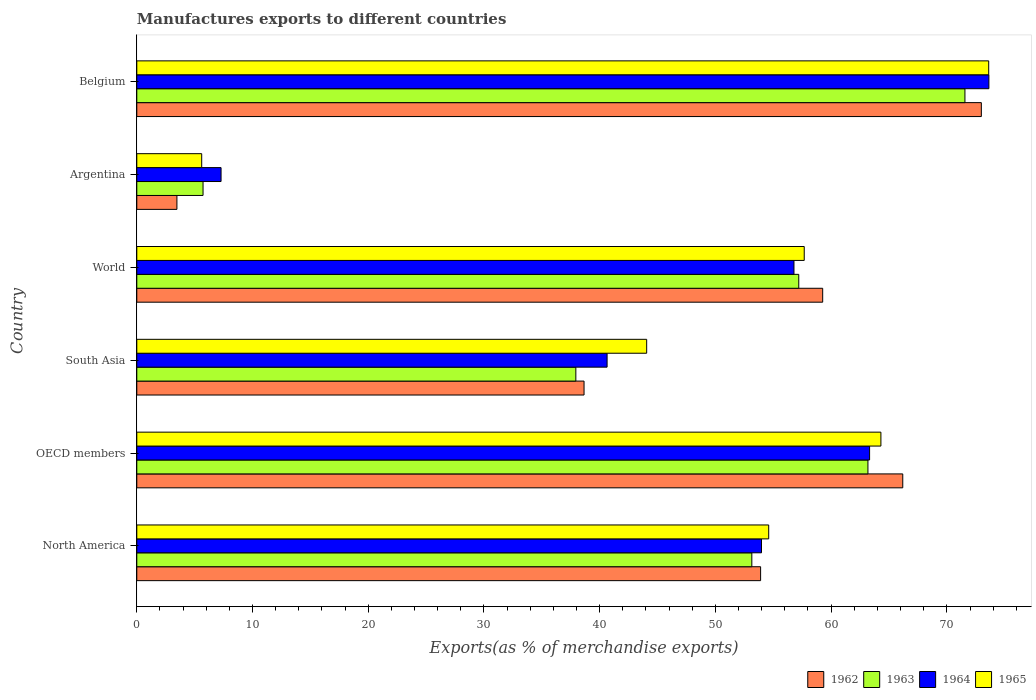How many different coloured bars are there?
Your response must be concise. 4. How many groups of bars are there?
Your answer should be very brief. 6. How many bars are there on the 1st tick from the top?
Give a very brief answer. 4. In how many cases, is the number of bars for a given country not equal to the number of legend labels?
Offer a very short reply. 0. What is the percentage of exports to different countries in 1962 in OECD members?
Keep it short and to the point. 66.19. Across all countries, what is the maximum percentage of exports to different countries in 1964?
Give a very brief answer. 73.63. Across all countries, what is the minimum percentage of exports to different countries in 1964?
Provide a succinct answer. 7.28. In which country was the percentage of exports to different countries in 1962 maximum?
Provide a succinct answer. Belgium. What is the total percentage of exports to different countries in 1963 in the graph?
Keep it short and to the point. 288.76. What is the difference between the percentage of exports to different countries in 1962 in Argentina and that in OECD members?
Keep it short and to the point. -62.72. What is the difference between the percentage of exports to different countries in 1963 in Argentina and the percentage of exports to different countries in 1962 in World?
Keep it short and to the point. -53.54. What is the average percentage of exports to different countries in 1962 per country?
Offer a very short reply. 49.08. What is the difference between the percentage of exports to different countries in 1962 and percentage of exports to different countries in 1965 in North America?
Offer a very short reply. -0.7. What is the ratio of the percentage of exports to different countries in 1963 in Belgium to that in North America?
Your answer should be very brief. 1.35. Is the percentage of exports to different countries in 1962 in OECD members less than that in South Asia?
Give a very brief answer. No. What is the difference between the highest and the second highest percentage of exports to different countries in 1963?
Ensure brevity in your answer.  8.38. What is the difference between the highest and the lowest percentage of exports to different countries in 1962?
Ensure brevity in your answer.  69.51. Is the sum of the percentage of exports to different countries in 1963 in Argentina and OECD members greater than the maximum percentage of exports to different countries in 1965 across all countries?
Make the answer very short. No. What does the 4th bar from the top in Argentina represents?
Offer a very short reply. 1962. What does the 1st bar from the bottom in Argentina represents?
Give a very brief answer. 1962. Are all the bars in the graph horizontal?
Your answer should be compact. Yes. How many countries are there in the graph?
Your response must be concise. 6. What is the difference between two consecutive major ticks on the X-axis?
Your response must be concise. 10. Are the values on the major ticks of X-axis written in scientific E-notation?
Offer a terse response. No. Does the graph contain any zero values?
Provide a succinct answer. No. Does the graph contain grids?
Provide a short and direct response. No. How many legend labels are there?
Give a very brief answer. 4. What is the title of the graph?
Ensure brevity in your answer.  Manufactures exports to different countries. Does "2000" appear as one of the legend labels in the graph?
Offer a very short reply. No. What is the label or title of the X-axis?
Provide a succinct answer. Exports(as % of merchandise exports). What is the label or title of the Y-axis?
Offer a terse response. Country. What is the Exports(as % of merchandise exports) of 1962 in North America?
Make the answer very short. 53.91. What is the Exports(as % of merchandise exports) of 1963 in North America?
Offer a terse response. 53.15. What is the Exports(as % of merchandise exports) in 1964 in North America?
Ensure brevity in your answer.  53.98. What is the Exports(as % of merchandise exports) in 1965 in North America?
Offer a very short reply. 54.61. What is the Exports(as % of merchandise exports) of 1962 in OECD members?
Your answer should be very brief. 66.19. What is the Exports(as % of merchandise exports) in 1963 in OECD members?
Provide a short and direct response. 63.18. What is the Exports(as % of merchandise exports) in 1964 in OECD members?
Keep it short and to the point. 63.32. What is the Exports(as % of merchandise exports) in 1965 in OECD members?
Provide a short and direct response. 64.3. What is the Exports(as % of merchandise exports) of 1962 in South Asia?
Your answer should be very brief. 38.65. What is the Exports(as % of merchandise exports) of 1963 in South Asia?
Make the answer very short. 37.94. What is the Exports(as % of merchandise exports) in 1964 in South Asia?
Your response must be concise. 40.64. What is the Exports(as % of merchandise exports) in 1965 in South Asia?
Offer a very short reply. 44.06. What is the Exports(as % of merchandise exports) in 1962 in World?
Keep it short and to the point. 59.27. What is the Exports(as % of merchandise exports) of 1963 in World?
Provide a succinct answer. 57.2. What is the Exports(as % of merchandise exports) of 1964 in World?
Give a very brief answer. 56.79. What is the Exports(as % of merchandise exports) of 1965 in World?
Your answer should be very brief. 57.68. What is the Exports(as % of merchandise exports) of 1962 in Argentina?
Provide a short and direct response. 3.47. What is the Exports(as % of merchandise exports) in 1963 in Argentina?
Keep it short and to the point. 5.73. What is the Exports(as % of merchandise exports) of 1964 in Argentina?
Give a very brief answer. 7.28. What is the Exports(as % of merchandise exports) of 1965 in Argentina?
Provide a succinct answer. 5.61. What is the Exports(as % of merchandise exports) of 1962 in Belgium?
Your answer should be very brief. 72.98. What is the Exports(as % of merchandise exports) of 1963 in Belgium?
Ensure brevity in your answer.  71.56. What is the Exports(as % of merchandise exports) in 1964 in Belgium?
Provide a succinct answer. 73.63. What is the Exports(as % of merchandise exports) in 1965 in Belgium?
Make the answer very short. 73.62. Across all countries, what is the maximum Exports(as % of merchandise exports) in 1962?
Your response must be concise. 72.98. Across all countries, what is the maximum Exports(as % of merchandise exports) in 1963?
Ensure brevity in your answer.  71.56. Across all countries, what is the maximum Exports(as % of merchandise exports) in 1964?
Your answer should be compact. 73.63. Across all countries, what is the maximum Exports(as % of merchandise exports) of 1965?
Keep it short and to the point. 73.62. Across all countries, what is the minimum Exports(as % of merchandise exports) of 1962?
Your answer should be very brief. 3.47. Across all countries, what is the minimum Exports(as % of merchandise exports) of 1963?
Give a very brief answer. 5.73. Across all countries, what is the minimum Exports(as % of merchandise exports) in 1964?
Ensure brevity in your answer.  7.28. Across all countries, what is the minimum Exports(as % of merchandise exports) in 1965?
Provide a succinct answer. 5.61. What is the total Exports(as % of merchandise exports) in 1962 in the graph?
Your answer should be very brief. 294.46. What is the total Exports(as % of merchandise exports) of 1963 in the graph?
Your answer should be very brief. 288.76. What is the total Exports(as % of merchandise exports) in 1964 in the graph?
Offer a terse response. 295.65. What is the total Exports(as % of merchandise exports) of 1965 in the graph?
Your answer should be compact. 299.87. What is the difference between the Exports(as % of merchandise exports) of 1962 in North America and that in OECD members?
Your answer should be compact. -12.28. What is the difference between the Exports(as % of merchandise exports) of 1963 in North America and that in OECD members?
Make the answer very short. -10.03. What is the difference between the Exports(as % of merchandise exports) of 1964 in North America and that in OECD members?
Keep it short and to the point. -9.34. What is the difference between the Exports(as % of merchandise exports) in 1965 in North America and that in OECD members?
Your answer should be very brief. -9.7. What is the difference between the Exports(as % of merchandise exports) of 1962 in North America and that in South Asia?
Keep it short and to the point. 15.26. What is the difference between the Exports(as % of merchandise exports) of 1963 in North America and that in South Asia?
Keep it short and to the point. 15.21. What is the difference between the Exports(as % of merchandise exports) of 1964 in North America and that in South Asia?
Offer a very short reply. 13.34. What is the difference between the Exports(as % of merchandise exports) of 1965 in North America and that in South Asia?
Your answer should be compact. 10.54. What is the difference between the Exports(as % of merchandise exports) in 1962 in North America and that in World?
Your response must be concise. -5.36. What is the difference between the Exports(as % of merchandise exports) in 1963 in North America and that in World?
Provide a short and direct response. -4.06. What is the difference between the Exports(as % of merchandise exports) in 1964 in North America and that in World?
Offer a terse response. -2.81. What is the difference between the Exports(as % of merchandise exports) in 1965 in North America and that in World?
Your answer should be very brief. -3.07. What is the difference between the Exports(as % of merchandise exports) of 1962 in North America and that in Argentina?
Make the answer very short. 50.44. What is the difference between the Exports(as % of merchandise exports) of 1963 in North America and that in Argentina?
Make the answer very short. 47.42. What is the difference between the Exports(as % of merchandise exports) in 1964 in North America and that in Argentina?
Your answer should be compact. 46.7. What is the difference between the Exports(as % of merchandise exports) in 1965 in North America and that in Argentina?
Give a very brief answer. 49. What is the difference between the Exports(as % of merchandise exports) in 1962 in North America and that in Belgium?
Your answer should be very brief. -19.07. What is the difference between the Exports(as % of merchandise exports) of 1963 in North America and that in Belgium?
Give a very brief answer. -18.42. What is the difference between the Exports(as % of merchandise exports) of 1964 in North America and that in Belgium?
Provide a short and direct response. -19.65. What is the difference between the Exports(as % of merchandise exports) in 1965 in North America and that in Belgium?
Offer a very short reply. -19.01. What is the difference between the Exports(as % of merchandise exports) in 1962 in OECD members and that in South Asia?
Provide a succinct answer. 27.54. What is the difference between the Exports(as % of merchandise exports) of 1963 in OECD members and that in South Asia?
Offer a terse response. 25.24. What is the difference between the Exports(as % of merchandise exports) in 1964 in OECD members and that in South Asia?
Ensure brevity in your answer.  22.68. What is the difference between the Exports(as % of merchandise exports) of 1965 in OECD members and that in South Asia?
Provide a short and direct response. 20.24. What is the difference between the Exports(as % of merchandise exports) in 1962 in OECD members and that in World?
Provide a succinct answer. 6.92. What is the difference between the Exports(as % of merchandise exports) in 1963 in OECD members and that in World?
Keep it short and to the point. 5.98. What is the difference between the Exports(as % of merchandise exports) in 1964 in OECD members and that in World?
Keep it short and to the point. 6.53. What is the difference between the Exports(as % of merchandise exports) in 1965 in OECD members and that in World?
Provide a succinct answer. 6.63. What is the difference between the Exports(as % of merchandise exports) in 1962 in OECD members and that in Argentina?
Offer a terse response. 62.72. What is the difference between the Exports(as % of merchandise exports) in 1963 in OECD members and that in Argentina?
Offer a very short reply. 57.46. What is the difference between the Exports(as % of merchandise exports) of 1964 in OECD members and that in Argentina?
Your answer should be compact. 56.04. What is the difference between the Exports(as % of merchandise exports) of 1965 in OECD members and that in Argentina?
Your response must be concise. 58.69. What is the difference between the Exports(as % of merchandise exports) of 1962 in OECD members and that in Belgium?
Offer a very short reply. -6.79. What is the difference between the Exports(as % of merchandise exports) in 1963 in OECD members and that in Belgium?
Offer a terse response. -8.38. What is the difference between the Exports(as % of merchandise exports) in 1964 in OECD members and that in Belgium?
Offer a terse response. -10.31. What is the difference between the Exports(as % of merchandise exports) in 1965 in OECD members and that in Belgium?
Your response must be concise. -9.32. What is the difference between the Exports(as % of merchandise exports) of 1962 in South Asia and that in World?
Give a very brief answer. -20.62. What is the difference between the Exports(as % of merchandise exports) of 1963 in South Asia and that in World?
Ensure brevity in your answer.  -19.26. What is the difference between the Exports(as % of merchandise exports) of 1964 in South Asia and that in World?
Provide a short and direct response. -16.15. What is the difference between the Exports(as % of merchandise exports) of 1965 in South Asia and that in World?
Give a very brief answer. -13.62. What is the difference between the Exports(as % of merchandise exports) of 1962 in South Asia and that in Argentina?
Keep it short and to the point. 35.18. What is the difference between the Exports(as % of merchandise exports) in 1963 in South Asia and that in Argentina?
Give a very brief answer. 32.21. What is the difference between the Exports(as % of merchandise exports) in 1964 in South Asia and that in Argentina?
Offer a terse response. 33.36. What is the difference between the Exports(as % of merchandise exports) in 1965 in South Asia and that in Argentina?
Make the answer very short. 38.45. What is the difference between the Exports(as % of merchandise exports) in 1962 in South Asia and that in Belgium?
Ensure brevity in your answer.  -34.33. What is the difference between the Exports(as % of merchandise exports) in 1963 in South Asia and that in Belgium?
Give a very brief answer. -33.62. What is the difference between the Exports(as % of merchandise exports) of 1964 in South Asia and that in Belgium?
Make the answer very short. -32.99. What is the difference between the Exports(as % of merchandise exports) of 1965 in South Asia and that in Belgium?
Provide a succinct answer. -29.56. What is the difference between the Exports(as % of merchandise exports) in 1962 in World and that in Argentina?
Ensure brevity in your answer.  55.8. What is the difference between the Exports(as % of merchandise exports) in 1963 in World and that in Argentina?
Make the answer very short. 51.48. What is the difference between the Exports(as % of merchandise exports) in 1964 in World and that in Argentina?
Your answer should be compact. 49.51. What is the difference between the Exports(as % of merchandise exports) of 1965 in World and that in Argentina?
Provide a succinct answer. 52.07. What is the difference between the Exports(as % of merchandise exports) of 1962 in World and that in Belgium?
Your response must be concise. -13.71. What is the difference between the Exports(as % of merchandise exports) in 1963 in World and that in Belgium?
Provide a short and direct response. -14.36. What is the difference between the Exports(as % of merchandise exports) in 1964 in World and that in Belgium?
Your answer should be very brief. -16.84. What is the difference between the Exports(as % of merchandise exports) in 1965 in World and that in Belgium?
Offer a terse response. -15.94. What is the difference between the Exports(as % of merchandise exports) of 1962 in Argentina and that in Belgium?
Make the answer very short. -69.51. What is the difference between the Exports(as % of merchandise exports) in 1963 in Argentina and that in Belgium?
Your answer should be very brief. -65.84. What is the difference between the Exports(as % of merchandise exports) of 1964 in Argentina and that in Belgium?
Give a very brief answer. -66.35. What is the difference between the Exports(as % of merchandise exports) in 1965 in Argentina and that in Belgium?
Provide a short and direct response. -68.01. What is the difference between the Exports(as % of merchandise exports) in 1962 in North America and the Exports(as % of merchandise exports) in 1963 in OECD members?
Your response must be concise. -9.27. What is the difference between the Exports(as % of merchandise exports) of 1962 in North America and the Exports(as % of merchandise exports) of 1964 in OECD members?
Offer a very short reply. -9.42. What is the difference between the Exports(as % of merchandise exports) in 1962 in North America and the Exports(as % of merchandise exports) in 1965 in OECD members?
Provide a short and direct response. -10.4. What is the difference between the Exports(as % of merchandise exports) in 1963 in North America and the Exports(as % of merchandise exports) in 1964 in OECD members?
Offer a very short reply. -10.18. What is the difference between the Exports(as % of merchandise exports) of 1963 in North America and the Exports(as % of merchandise exports) of 1965 in OECD members?
Provide a succinct answer. -11.15. What is the difference between the Exports(as % of merchandise exports) in 1964 in North America and the Exports(as % of merchandise exports) in 1965 in OECD members?
Give a very brief answer. -10.32. What is the difference between the Exports(as % of merchandise exports) of 1962 in North America and the Exports(as % of merchandise exports) of 1963 in South Asia?
Make the answer very short. 15.97. What is the difference between the Exports(as % of merchandise exports) in 1962 in North America and the Exports(as % of merchandise exports) in 1964 in South Asia?
Offer a terse response. 13.27. What is the difference between the Exports(as % of merchandise exports) of 1962 in North America and the Exports(as % of merchandise exports) of 1965 in South Asia?
Provide a short and direct response. 9.85. What is the difference between the Exports(as % of merchandise exports) of 1963 in North America and the Exports(as % of merchandise exports) of 1964 in South Asia?
Offer a very short reply. 12.51. What is the difference between the Exports(as % of merchandise exports) of 1963 in North America and the Exports(as % of merchandise exports) of 1965 in South Asia?
Ensure brevity in your answer.  9.09. What is the difference between the Exports(as % of merchandise exports) of 1964 in North America and the Exports(as % of merchandise exports) of 1965 in South Asia?
Provide a short and direct response. 9.92. What is the difference between the Exports(as % of merchandise exports) of 1962 in North America and the Exports(as % of merchandise exports) of 1963 in World?
Your response must be concise. -3.3. What is the difference between the Exports(as % of merchandise exports) in 1962 in North America and the Exports(as % of merchandise exports) in 1964 in World?
Make the answer very short. -2.88. What is the difference between the Exports(as % of merchandise exports) of 1962 in North America and the Exports(as % of merchandise exports) of 1965 in World?
Offer a terse response. -3.77. What is the difference between the Exports(as % of merchandise exports) in 1963 in North America and the Exports(as % of merchandise exports) in 1964 in World?
Offer a very short reply. -3.64. What is the difference between the Exports(as % of merchandise exports) of 1963 in North America and the Exports(as % of merchandise exports) of 1965 in World?
Your answer should be very brief. -4.53. What is the difference between the Exports(as % of merchandise exports) of 1964 in North America and the Exports(as % of merchandise exports) of 1965 in World?
Offer a very short reply. -3.69. What is the difference between the Exports(as % of merchandise exports) in 1962 in North America and the Exports(as % of merchandise exports) in 1963 in Argentina?
Give a very brief answer. 48.18. What is the difference between the Exports(as % of merchandise exports) of 1962 in North America and the Exports(as % of merchandise exports) of 1964 in Argentina?
Make the answer very short. 46.62. What is the difference between the Exports(as % of merchandise exports) in 1962 in North America and the Exports(as % of merchandise exports) in 1965 in Argentina?
Give a very brief answer. 48.3. What is the difference between the Exports(as % of merchandise exports) in 1963 in North America and the Exports(as % of merchandise exports) in 1964 in Argentina?
Your answer should be very brief. 45.87. What is the difference between the Exports(as % of merchandise exports) in 1963 in North America and the Exports(as % of merchandise exports) in 1965 in Argentina?
Make the answer very short. 47.54. What is the difference between the Exports(as % of merchandise exports) of 1964 in North America and the Exports(as % of merchandise exports) of 1965 in Argentina?
Provide a succinct answer. 48.37. What is the difference between the Exports(as % of merchandise exports) of 1962 in North America and the Exports(as % of merchandise exports) of 1963 in Belgium?
Your answer should be very brief. -17.66. What is the difference between the Exports(as % of merchandise exports) in 1962 in North America and the Exports(as % of merchandise exports) in 1964 in Belgium?
Keep it short and to the point. -19.73. What is the difference between the Exports(as % of merchandise exports) in 1962 in North America and the Exports(as % of merchandise exports) in 1965 in Belgium?
Give a very brief answer. -19.71. What is the difference between the Exports(as % of merchandise exports) of 1963 in North America and the Exports(as % of merchandise exports) of 1964 in Belgium?
Your answer should be very brief. -20.49. What is the difference between the Exports(as % of merchandise exports) in 1963 in North America and the Exports(as % of merchandise exports) in 1965 in Belgium?
Offer a very short reply. -20.47. What is the difference between the Exports(as % of merchandise exports) in 1964 in North America and the Exports(as % of merchandise exports) in 1965 in Belgium?
Provide a succinct answer. -19.63. What is the difference between the Exports(as % of merchandise exports) of 1962 in OECD members and the Exports(as % of merchandise exports) of 1963 in South Asia?
Your answer should be very brief. 28.25. What is the difference between the Exports(as % of merchandise exports) in 1962 in OECD members and the Exports(as % of merchandise exports) in 1964 in South Asia?
Ensure brevity in your answer.  25.55. What is the difference between the Exports(as % of merchandise exports) of 1962 in OECD members and the Exports(as % of merchandise exports) of 1965 in South Asia?
Ensure brevity in your answer.  22.13. What is the difference between the Exports(as % of merchandise exports) of 1963 in OECD members and the Exports(as % of merchandise exports) of 1964 in South Asia?
Ensure brevity in your answer.  22.54. What is the difference between the Exports(as % of merchandise exports) in 1963 in OECD members and the Exports(as % of merchandise exports) in 1965 in South Asia?
Offer a very short reply. 19.12. What is the difference between the Exports(as % of merchandise exports) in 1964 in OECD members and the Exports(as % of merchandise exports) in 1965 in South Asia?
Give a very brief answer. 19.26. What is the difference between the Exports(as % of merchandise exports) of 1962 in OECD members and the Exports(as % of merchandise exports) of 1963 in World?
Your response must be concise. 8.99. What is the difference between the Exports(as % of merchandise exports) in 1962 in OECD members and the Exports(as % of merchandise exports) in 1964 in World?
Your response must be concise. 9.4. What is the difference between the Exports(as % of merchandise exports) of 1962 in OECD members and the Exports(as % of merchandise exports) of 1965 in World?
Offer a very short reply. 8.51. What is the difference between the Exports(as % of merchandise exports) of 1963 in OECD members and the Exports(as % of merchandise exports) of 1964 in World?
Give a very brief answer. 6.39. What is the difference between the Exports(as % of merchandise exports) in 1963 in OECD members and the Exports(as % of merchandise exports) in 1965 in World?
Offer a terse response. 5.5. What is the difference between the Exports(as % of merchandise exports) in 1964 in OECD members and the Exports(as % of merchandise exports) in 1965 in World?
Your answer should be very brief. 5.65. What is the difference between the Exports(as % of merchandise exports) in 1962 in OECD members and the Exports(as % of merchandise exports) in 1963 in Argentina?
Keep it short and to the point. 60.46. What is the difference between the Exports(as % of merchandise exports) of 1962 in OECD members and the Exports(as % of merchandise exports) of 1964 in Argentina?
Your answer should be very brief. 58.91. What is the difference between the Exports(as % of merchandise exports) in 1962 in OECD members and the Exports(as % of merchandise exports) in 1965 in Argentina?
Offer a very short reply. 60.58. What is the difference between the Exports(as % of merchandise exports) in 1963 in OECD members and the Exports(as % of merchandise exports) in 1964 in Argentina?
Your answer should be compact. 55.9. What is the difference between the Exports(as % of merchandise exports) of 1963 in OECD members and the Exports(as % of merchandise exports) of 1965 in Argentina?
Provide a short and direct response. 57.57. What is the difference between the Exports(as % of merchandise exports) of 1964 in OECD members and the Exports(as % of merchandise exports) of 1965 in Argentina?
Offer a very short reply. 57.71. What is the difference between the Exports(as % of merchandise exports) in 1962 in OECD members and the Exports(as % of merchandise exports) in 1963 in Belgium?
Your response must be concise. -5.37. What is the difference between the Exports(as % of merchandise exports) in 1962 in OECD members and the Exports(as % of merchandise exports) in 1964 in Belgium?
Your answer should be very brief. -7.44. What is the difference between the Exports(as % of merchandise exports) in 1962 in OECD members and the Exports(as % of merchandise exports) in 1965 in Belgium?
Ensure brevity in your answer.  -7.43. What is the difference between the Exports(as % of merchandise exports) of 1963 in OECD members and the Exports(as % of merchandise exports) of 1964 in Belgium?
Keep it short and to the point. -10.45. What is the difference between the Exports(as % of merchandise exports) of 1963 in OECD members and the Exports(as % of merchandise exports) of 1965 in Belgium?
Your answer should be compact. -10.44. What is the difference between the Exports(as % of merchandise exports) of 1964 in OECD members and the Exports(as % of merchandise exports) of 1965 in Belgium?
Ensure brevity in your answer.  -10.29. What is the difference between the Exports(as % of merchandise exports) of 1962 in South Asia and the Exports(as % of merchandise exports) of 1963 in World?
Provide a short and direct response. -18.56. What is the difference between the Exports(as % of merchandise exports) of 1962 in South Asia and the Exports(as % of merchandise exports) of 1964 in World?
Your answer should be very brief. -18.14. What is the difference between the Exports(as % of merchandise exports) in 1962 in South Asia and the Exports(as % of merchandise exports) in 1965 in World?
Offer a very short reply. -19.03. What is the difference between the Exports(as % of merchandise exports) in 1963 in South Asia and the Exports(as % of merchandise exports) in 1964 in World?
Provide a short and direct response. -18.85. What is the difference between the Exports(as % of merchandise exports) of 1963 in South Asia and the Exports(as % of merchandise exports) of 1965 in World?
Your response must be concise. -19.74. What is the difference between the Exports(as % of merchandise exports) in 1964 in South Asia and the Exports(as % of merchandise exports) in 1965 in World?
Provide a short and direct response. -17.04. What is the difference between the Exports(as % of merchandise exports) of 1962 in South Asia and the Exports(as % of merchandise exports) of 1963 in Argentina?
Offer a very short reply. 32.92. What is the difference between the Exports(as % of merchandise exports) of 1962 in South Asia and the Exports(as % of merchandise exports) of 1964 in Argentina?
Give a very brief answer. 31.37. What is the difference between the Exports(as % of merchandise exports) in 1962 in South Asia and the Exports(as % of merchandise exports) in 1965 in Argentina?
Offer a very short reply. 33.04. What is the difference between the Exports(as % of merchandise exports) of 1963 in South Asia and the Exports(as % of merchandise exports) of 1964 in Argentina?
Provide a succinct answer. 30.66. What is the difference between the Exports(as % of merchandise exports) of 1963 in South Asia and the Exports(as % of merchandise exports) of 1965 in Argentina?
Make the answer very short. 32.33. What is the difference between the Exports(as % of merchandise exports) of 1964 in South Asia and the Exports(as % of merchandise exports) of 1965 in Argentina?
Your response must be concise. 35.03. What is the difference between the Exports(as % of merchandise exports) in 1962 in South Asia and the Exports(as % of merchandise exports) in 1963 in Belgium?
Ensure brevity in your answer.  -32.92. What is the difference between the Exports(as % of merchandise exports) in 1962 in South Asia and the Exports(as % of merchandise exports) in 1964 in Belgium?
Give a very brief answer. -34.98. What is the difference between the Exports(as % of merchandise exports) of 1962 in South Asia and the Exports(as % of merchandise exports) of 1965 in Belgium?
Your answer should be compact. -34.97. What is the difference between the Exports(as % of merchandise exports) in 1963 in South Asia and the Exports(as % of merchandise exports) in 1964 in Belgium?
Keep it short and to the point. -35.69. What is the difference between the Exports(as % of merchandise exports) of 1963 in South Asia and the Exports(as % of merchandise exports) of 1965 in Belgium?
Give a very brief answer. -35.68. What is the difference between the Exports(as % of merchandise exports) of 1964 in South Asia and the Exports(as % of merchandise exports) of 1965 in Belgium?
Ensure brevity in your answer.  -32.98. What is the difference between the Exports(as % of merchandise exports) in 1962 in World and the Exports(as % of merchandise exports) in 1963 in Argentina?
Give a very brief answer. 53.55. What is the difference between the Exports(as % of merchandise exports) in 1962 in World and the Exports(as % of merchandise exports) in 1964 in Argentina?
Your response must be concise. 51.99. What is the difference between the Exports(as % of merchandise exports) of 1962 in World and the Exports(as % of merchandise exports) of 1965 in Argentina?
Provide a succinct answer. 53.66. What is the difference between the Exports(as % of merchandise exports) of 1963 in World and the Exports(as % of merchandise exports) of 1964 in Argentina?
Give a very brief answer. 49.92. What is the difference between the Exports(as % of merchandise exports) in 1963 in World and the Exports(as % of merchandise exports) in 1965 in Argentina?
Your response must be concise. 51.59. What is the difference between the Exports(as % of merchandise exports) in 1964 in World and the Exports(as % of merchandise exports) in 1965 in Argentina?
Keep it short and to the point. 51.18. What is the difference between the Exports(as % of merchandise exports) of 1962 in World and the Exports(as % of merchandise exports) of 1963 in Belgium?
Offer a terse response. -12.29. What is the difference between the Exports(as % of merchandise exports) of 1962 in World and the Exports(as % of merchandise exports) of 1964 in Belgium?
Your answer should be compact. -14.36. What is the difference between the Exports(as % of merchandise exports) in 1962 in World and the Exports(as % of merchandise exports) in 1965 in Belgium?
Provide a short and direct response. -14.35. What is the difference between the Exports(as % of merchandise exports) of 1963 in World and the Exports(as % of merchandise exports) of 1964 in Belgium?
Give a very brief answer. -16.43. What is the difference between the Exports(as % of merchandise exports) of 1963 in World and the Exports(as % of merchandise exports) of 1965 in Belgium?
Keep it short and to the point. -16.41. What is the difference between the Exports(as % of merchandise exports) of 1964 in World and the Exports(as % of merchandise exports) of 1965 in Belgium?
Provide a succinct answer. -16.83. What is the difference between the Exports(as % of merchandise exports) of 1962 in Argentina and the Exports(as % of merchandise exports) of 1963 in Belgium?
Make the answer very short. -68.1. What is the difference between the Exports(as % of merchandise exports) in 1962 in Argentina and the Exports(as % of merchandise exports) in 1964 in Belgium?
Keep it short and to the point. -70.16. What is the difference between the Exports(as % of merchandise exports) of 1962 in Argentina and the Exports(as % of merchandise exports) of 1965 in Belgium?
Ensure brevity in your answer.  -70.15. What is the difference between the Exports(as % of merchandise exports) of 1963 in Argentina and the Exports(as % of merchandise exports) of 1964 in Belgium?
Keep it short and to the point. -67.91. What is the difference between the Exports(as % of merchandise exports) of 1963 in Argentina and the Exports(as % of merchandise exports) of 1965 in Belgium?
Give a very brief answer. -67.89. What is the difference between the Exports(as % of merchandise exports) in 1964 in Argentina and the Exports(as % of merchandise exports) in 1965 in Belgium?
Your response must be concise. -66.33. What is the average Exports(as % of merchandise exports) in 1962 per country?
Provide a succinct answer. 49.08. What is the average Exports(as % of merchandise exports) in 1963 per country?
Your answer should be very brief. 48.13. What is the average Exports(as % of merchandise exports) of 1964 per country?
Ensure brevity in your answer.  49.28. What is the average Exports(as % of merchandise exports) of 1965 per country?
Make the answer very short. 49.98. What is the difference between the Exports(as % of merchandise exports) in 1962 and Exports(as % of merchandise exports) in 1963 in North America?
Your answer should be compact. 0.76. What is the difference between the Exports(as % of merchandise exports) of 1962 and Exports(as % of merchandise exports) of 1964 in North America?
Make the answer very short. -0.08. What is the difference between the Exports(as % of merchandise exports) of 1962 and Exports(as % of merchandise exports) of 1965 in North America?
Ensure brevity in your answer.  -0.7. What is the difference between the Exports(as % of merchandise exports) of 1963 and Exports(as % of merchandise exports) of 1964 in North America?
Ensure brevity in your answer.  -0.84. What is the difference between the Exports(as % of merchandise exports) of 1963 and Exports(as % of merchandise exports) of 1965 in North America?
Your answer should be compact. -1.46. What is the difference between the Exports(as % of merchandise exports) of 1964 and Exports(as % of merchandise exports) of 1965 in North America?
Provide a succinct answer. -0.62. What is the difference between the Exports(as % of merchandise exports) in 1962 and Exports(as % of merchandise exports) in 1963 in OECD members?
Provide a short and direct response. 3.01. What is the difference between the Exports(as % of merchandise exports) in 1962 and Exports(as % of merchandise exports) in 1964 in OECD members?
Provide a succinct answer. 2.87. What is the difference between the Exports(as % of merchandise exports) of 1962 and Exports(as % of merchandise exports) of 1965 in OECD members?
Your answer should be very brief. 1.89. What is the difference between the Exports(as % of merchandise exports) in 1963 and Exports(as % of merchandise exports) in 1964 in OECD members?
Offer a terse response. -0.14. What is the difference between the Exports(as % of merchandise exports) in 1963 and Exports(as % of merchandise exports) in 1965 in OECD members?
Your answer should be compact. -1.12. What is the difference between the Exports(as % of merchandise exports) in 1964 and Exports(as % of merchandise exports) in 1965 in OECD members?
Your answer should be very brief. -0.98. What is the difference between the Exports(as % of merchandise exports) of 1962 and Exports(as % of merchandise exports) of 1963 in South Asia?
Provide a short and direct response. 0.71. What is the difference between the Exports(as % of merchandise exports) of 1962 and Exports(as % of merchandise exports) of 1964 in South Asia?
Make the answer very short. -1.99. What is the difference between the Exports(as % of merchandise exports) in 1962 and Exports(as % of merchandise exports) in 1965 in South Asia?
Make the answer very short. -5.41. What is the difference between the Exports(as % of merchandise exports) in 1963 and Exports(as % of merchandise exports) in 1964 in South Asia?
Your answer should be compact. -2.7. What is the difference between the Exports(as % of merchandise exports) in 1963 and Exports(as % of merchandise exports) in 1965 in South Asia?
Your answer should be compact. -6.12. What is the difference between the Exports(as % of merchandise exports) of 1964 and Exports(as % of merchandise exports) of 1965 in South Asia?
Give a very brief answer. -3.42. What is the difference between the Exports(as % of merchandise exports) in 1962 and Exports(as % of merchandise exports) in 1963 in World?
Ensure brevity in your answer.  2.07. What is the difference between the Exports(as % of merchandise exports) in 1962 and Exports(as % of merchandise exports) in 1964 in World?
Ensure brevity in your answer.  2.48. What is the difference between the Exports(as % of merchandise exports) of 1962 and Exports(as % of merchandise exports) of 1965 in World?
Keep it short and to the point. 1.59. What is the difference between the Exports(as % of merchandise exports) in 1963 and Exports(as % of merchandise exports) in 1964 in World?
Keep it short and to the point. 0.41. What is the difference between the Exports(as % of merchandise exports) of 1963 and Exports(as % of merchandise exports) of 1965 in World?
Your answer should be compact. -0.47. What is the difference between the Exports(as % of merchandise exports) in 1964 and Exports(as % of merchandise exports) in 1965 in World?
Keep it short and to the point. -0.89. What is the difference between the Exports(as % of merchandise exports) in 1962 and Exports(as % of merchandise exports) in 1963 in Argentina?
Provide a short and direct response. -2.26. What is the difference between the Exports(as % of merchandise exports) in 1962 and Exports(as % of merchandise exports) in 1964 in Argentina?
Make the answer very short. -3.81. What is the difference between the Exports(as % of merchandise exports) of 1962 and Exports(as % of merchandise exports) of 1965 in Argentina?
Your answer should be compact. -2.14. What is the difference between the Exports(as % of merchandise exports) in 1963 and Exports(as % of merchandise exports) in 1964 in Argentina?
Ensure brevity in your answer.  -1.56. What is the difference between the Exports(as % of merchandise exports) in 1963 and Exports(as % of merchandise exports) in 1965 in Argentina?
Keep it short and to the point. 0.12. What is the difference between the Exports(as % of merchandise exports) of 1964 and Exports(as % of merchandise exports) of 1965 in Argentina?
Provide a succinct answer. 1.67. What is the difference between the Exports(as % of merchandise exports) of 1962 and Exports(as % of merchandise exports) of 1963 in Belgium?
Offer a very short reply. 1.42. What is the difference between the Exports(as % of merchandise exports) of 1962 and Exports(as % of merchandise exports) of 1964 in Belgium?
Your response must be concise. -0.65. What is the difference between the Exports(as % of merchandise exports) in 1962 and Exports(as % of merchandise exports) in 1965 in Belgium?
Provide a succinct answer. -0.64. What is the difference between the Exports(as % of merchandise exports) of 1963 and Exports(as % of merchandise exports) of 1964 in Belgium?
Give a very brief answer. -2.07. What is the difference between the Exports(as % of merchandise exports) of 1963 and Exports(as % of merchandise exports) of 1965 in Belgium?
Your answer should be compact. -2.05. What is the difference between the Exports(as % of merchandise exports) of 1964 and Exports(as % of merchandise exports) of 1965 in Belgium?
Your answer should be compact. 0.02. What is the ratio of the Exports(as % of merchandise exports) of 1962 in North America to that in OECD members?
Make the answer very short. 0.81. What is the ratio of the Exports(as % of merchandise exports) in 1963 in North America to that in OECD members?
Offer a very short reply. 0.84. What is the ratio of the Exports(as % of merchandise exports) of 1964 in North America to that in OECD members?
Make the answer very short. 0.85. What is the ratio of the Exports(as % of merchandise exports) in 1965 in North America to that in OECD members?
Provide a succinct answer. 0.85. What is the ratio of the Exports(as % of merchandise exports) in 1962 in North America to that in South Asia?
Offer a very short reply. 1.39. What is the ratio of the Exports(as % of merchandise exports) of 1963 in North America to that in South Asia?
Keep it short and to the point. 1.4. What is the ratio of the Exports(as % of merchandise exports) in 1964 in North America to that in South Asia?
Give a very brief answer. 1.33. What is the ratio of the Exports(as % of merchandise exports) in 1965 in North America to that in South Asia?
Offer a terse response. 1.24. What is the ratio of the Exports(as % of merchandise exports) in 1962 in North America to that in World?
Ensure brevity in your answer.  0.91. What is the ratio of the Exports(as % of merchandise exports) of 1963 in North America to that in World?
Provide a succinct answer. 0.93. What is the ratio of the Exports(as % of merchandise exports) of 1964 in North America to that in World?
Ensure brevity in your answer.  0.95. What is the ratio of the Exports(as % of merchandise exports) of 1965 in North America to that in World?
Make the answer very short. 0.95. What is the ratio of the Exports(as % of merchandise exports) in 1962 in North America to that in Argentina?
Ensure brevity in your answer.  15.54. What is the ratio of the Exports(as % of merchandise exports) in 1963 in North America to that in Argentina?
Provide a short and direct response. 9.28. What is the ratio of the Exports(as % of merchandise exports) in 1964 in North America to that in Argentina?
Ensure brevity in your answer.  7.41. What is the ratio of the Exports(as % of merchandise exports) in 1965 in North America to that in Argentina?
Make the answer very short. 9.74. What is the ratio of the Exports(as % of merchandise exports) in 1962 in North America to that in Belgium?
Offer a very short reply. 0.74. What is the ratio of the Exports(as % of merchandise exports) of 1963 in North America to that in Belgium?
Offer a very short reply. 0.74. What is the ratio of the Exports(as % of merchandise exports) of 1964 in North America to that in Belgium?
Offer a terse response. 0.73. What is the ratio of the Exports(as % of merchandise exports) of 1965 in North America to that in Belgium?
Provide a succinct answer. 0.74. What is the ratio of the Exports(as % of merchandise exports) of 1962 in OECD members to that in South Asia?
Keep it short and to the point. 1.71. What is the ratio of the Exports(as % of merchandise exports) in 1963 in OECD members to that in South Asia?
Provide a succinct answer. 1.67. What is the ratio of the Exports(as % of merchandise exports) of 1964 in OECD members to that in South Asia?
Your answer should be compact. 1.56. What is the ratio of the Exports(as % of merchandise exports) of 1965 in OECD members to that in South Asia?
Your response must be concise. 1.46. What is the ratio of the Exports(as % of merchandise exports) of 1962 in OECD members to that in World?
Ensure brevity in your answer.  1.12. What is the ratio of the Exports(as % of merchandise exports) in 1963 in OECD members to that in World?
Offer a terse response. 1.1. What is the ratio of the Exports(as % of merchandise exports) of 1964 in OECD members to that in World?
Your answer should be compact. 1.12. What is the ratio of the Exports(as % of merchandise exports) of 1965 in OECD members to that in World?
Provide a short and direct response. 1.11. What is the ratio of the Exports(as % of merchandise exports) of 1962 in OECD members to that in Argentina?
Give a very brief answer. 19.09. What is the ratio of the Exports(as % of merchandise exports) in 1963 in OECD members to that in Argentina?
Offer a very short reply. 11.03. What is the ratio of the Exports(as % of merchandise exports) in 1964 in OECD members to that in Argentina?
Offer a very short reply. 8.7. What is the ratio of the Exports(as % of merchandise exports) of 1965 in OECD members to that in Argentina?
Your answer should be very brief. 11.46. What is the ratio of the Exports(as % of merchandise exports) in 1962 in OECD members to that in Belgium?
Provide a succinct answer. 0.91. What is the ratio of the Exports(as % of merchandise exports) in 1963 in OECD members to that in Belgium?
Offer a terse response. 0.88. What is the ratio of the Exports(as % of merchandise exports) in 1964 in OECD members to that in Belgium?
Make the answer very short. 0.86. What is the ratio of the Exports(as % of merchandise exports) in 1965 in OECD members to that in Belgium?
Provide a succinct answer. 0.87. What is the ratio of the Exports(as % of merchandise exports) of 1962 in South Asia to that in World?
Make the answer very short. 0.65. What is the ratio of the Exports(as % of merchandise exports) of 1963 in South Asia to that in World?
Provide a succinct answer. 0.66. What is the ratio of the Exports(as % of merchandise exports) of 1964 in South Asia to that in World?
Your answer should be compact. 0.72. What is the ratio of the Exports(as % of merchandise exports) in 1965 in South Asia to that in World?
Your answer should be very brief. 0.76. What is the ratio of the Exports(as % of merchandise exports) in 1962 in South Asia to that in Argentina?
Provide a succinct answer. 11.14. What is the ratio of the Exports(as % of merchandise exports) in 1963 in South Asia to that in Argentina?
Give a very brief answer. 6.63. What is the ratio of the Exports(as % of merchandise exports) of 1964 in South Asia to that in Argentina?
Keep it short and to the point. 5.58. What is the ratio of the Exports(as % of merchandise exports) in 1965 in South Asia to that in Argentina?
Provide a short and direct response. 7.86. What is the ratio of the Exports(as % of merchandise exports) of 1962 in South Asia to that in Belgium?
Provide a short and direct response. 0.53. What is the ratio of the Exports(as % of merchandise exports) of 1963 in South Asia to that in Belgium?
Keep it short and to the point. 0.53. What is the ratio of the Exports(as % of merchandise exports) of 1964 in South Asia to that in Belgium?
Keep it short and to the point. 0.55. What is the ratio of the Exports(as % of merchandise exports) in 1965 in South Asia to that in Belgium?
Your response must be concise. 0.6. What is the ratio of the Exports(as % of merchandise exports) of 1962 in World to that in Argentina?
Provide a short and direct response. 17.09. What is the ratio of the Exports(as % of merchandise exports) in 1963 in World to that in Argentina?
Provide a short and direct response. 9.99. What is the ratio of the Exports(as % of merchandise exports) in 1964 in World to that in Argentina?
Make the answer very short. 7.8. What is the ratio of the Exports(as % of merchandise exports) in 1965 in World to that in Argentina?
Give a very brief answer. 10.28. What is the ratio of the Exports(as % of merchandise exports) of 1962 in World to that in Belgium?
Offer a very short reply. 0.81. What is the ratio of the Exports(as % of merchandise exports) in 1963 in World to that in Belgium?
Your answer should be compact. 0.8. What is the ratio of the Exports(as % of merchandise exports) in 1964 in World to that in Belgium?
Your response must be concise. 0.77. What is the ratio of the Exports(as % of merchandise exports) in 1965 in World to that in Belgium?
Keep it short and to the point. 0.78. What is the ratio of the Exports(as % of merchandise exports) in 1962 in Argentina to that in Belgium?
Provide a succinct answer. 0.05. What is the ratio of the Exports(as % of merchandise exports) in 1963 in Argentina to that in Belgium?
Keep it short and to the point. 0.08. What is the ratio of the Exports(as % of merchandise exports) of 1964 in Argentina to that in Belgium?
Your answer should be very brief. 0.1. What is the ratio of the Exports(as % of merchandise exports) in 1965 in Argentina to that in Belgium?
Offer a terse response. 0.08. What is the difference between the highest and the second highest Exports(as % of merchandise exports) in 1962?
Offer a very short reply. 6.79. What is the difference between the highest and the second highest Exports(as % of merchandise exports) in 1963?
Offer a very short reply. 8.38. What is the difference between the highest and the second highest Exports(as % of merchandise exports) in 1964?
Ensure brevity in your answer.  10.31. What is the difference between the highest and the second highest Exports(as % of merchandise exports) in 1965?
Keep it short and to the point. 9.32. What is the difference between the highest and the lowest Exports(as % of merchandise exports) of 1962?
Your response must be concise. 69.51. What is the difference between the highest and the lowest Exports(as % of merchandise exports) of 1963?
Offer a very short reply. 65.84. What is the difference between the highest and the lowest Exports(as % of merchandise exports) of 1964?
Your answer should be very brief. 66.35. What is the difference between the highest and the lowest Exports(as % of merchandise exports) of 1965?
Provide a succinct answer. 68.01. 